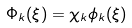Convert formula to latex. <formula><loc_0><loc_0><loc_500><loc_500>\Phi _ { k } ( \xi ) = \chi _ { k } \phi _ { k } ( \xi )</formula> 